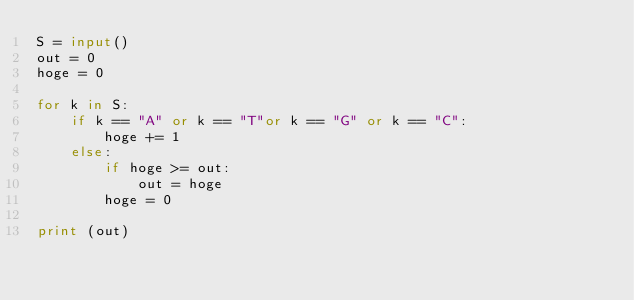<code> <loc_0><loc_0><loc_500><loc_500><_Python_>S = input()
out = 0
hoge = 0

for k in S:
    if k == "A" or k == "T"or k == "G" or k == "C":
        hoge += 1      
    else:
        if hoge >= out:
            out = hoge
        hoge = 0

print (out)</code> 